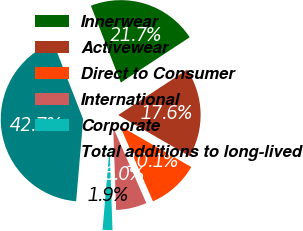Convert chart. <chart><loc_0><loc_0><loc_500><loc_500><pie_chart><fcel>Innerwear<fcel>Activewear<fcel>Direct to Consumer<fcel>International<fcel>Corporate<fcel>Total additions to long-lived<nl><fcel>21.66%<fcel>17.58%<fcel>10.09%<fcel>6.01%<fcel>1.93%<fcel>42.72%<nl></chart> 